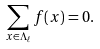<formula> <loc_0><loc_0><loc_500><loc_500>\sum _ { x \in \Lambda _ { \ell } } f ( x ) = 0 .</formula> 